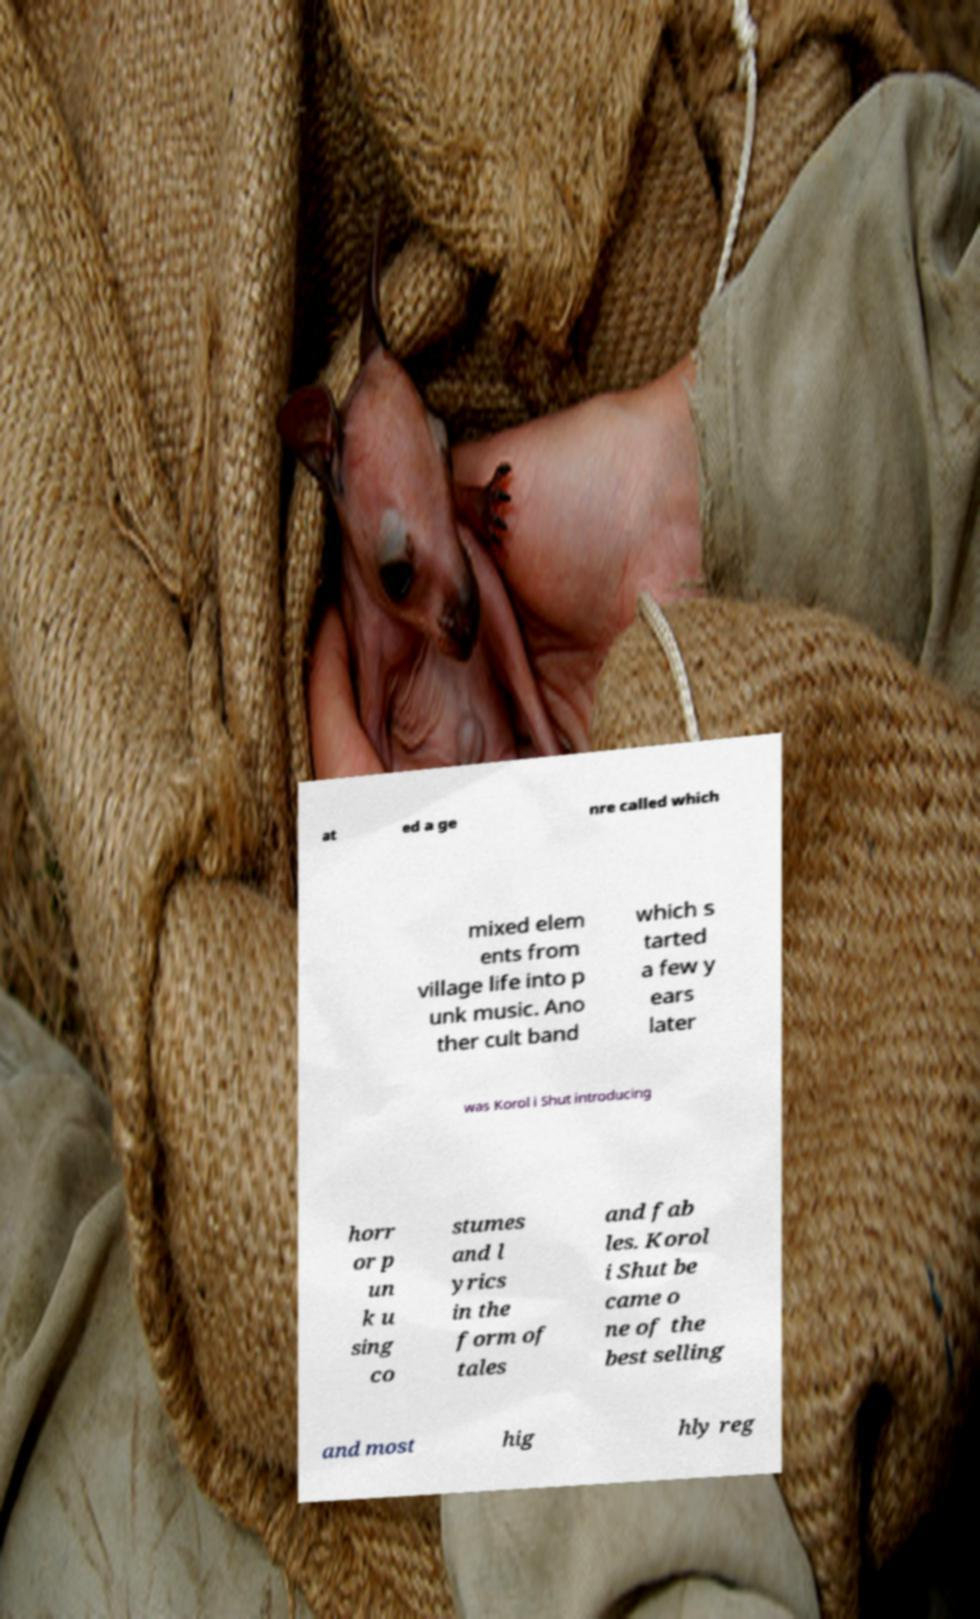Please read and relay the text visible in this image. What does it say? at ed a ge nre called which mixed elem ents from village life into p unk music. Ano ther cult band which s tarted a few y ears later was Korol i Shut introducing horr or p un k u sing co stumes and l yrics in the form of tales and fab les. Korol i Shut be came o ne of the best selling and most hig hly reg 